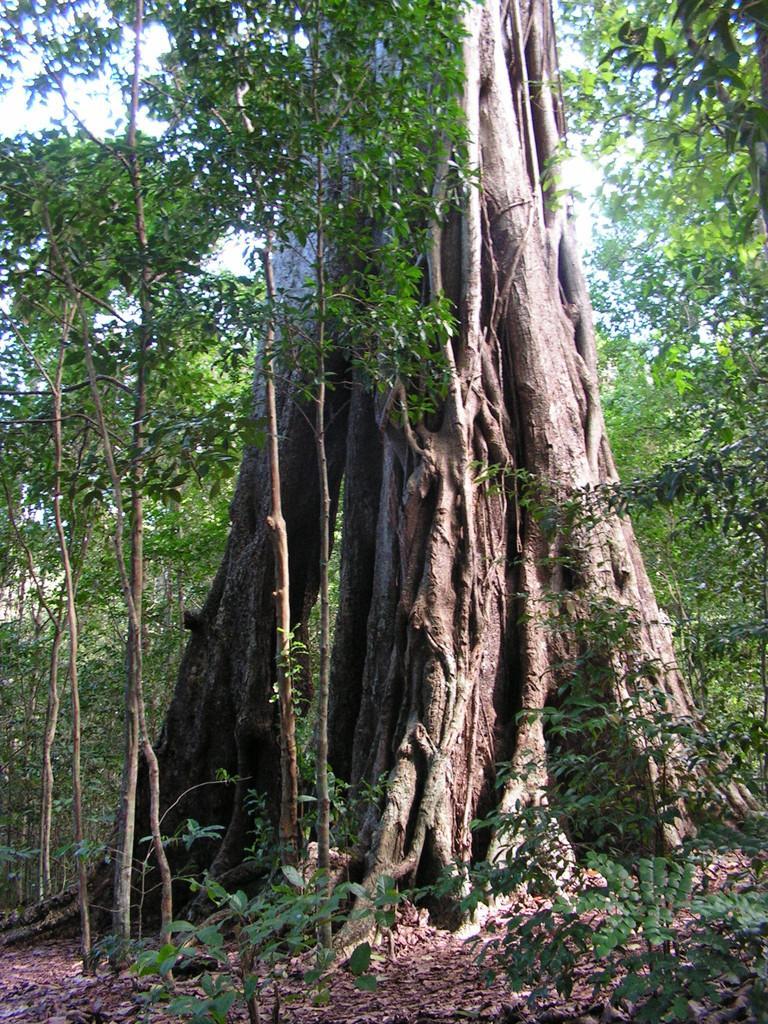Can you describe this image briefly? In the image we can see trees, plants, dry leaves and the sky. 